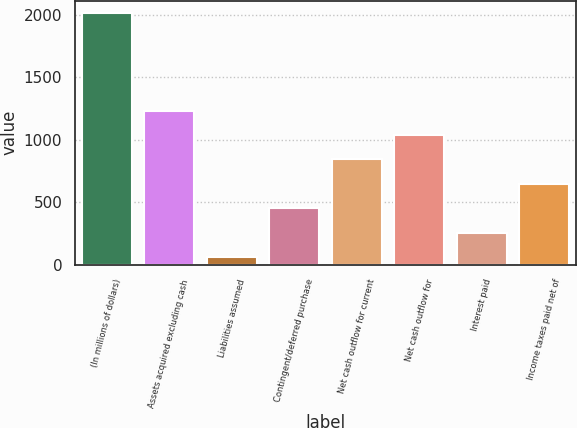Convert chart. <chart><loc_0><loc_0><loc_500><loc_500><bar_chart><fcel>(In millions of dollars)<fcel>Assets acquired excluding cash<fcel>Liabilities assumed<fcel>Contingent/deferred purchase<fcel>Net cash outflow for current<fcel>Net cash outflow for<fcel>Interest paid<fcel>Income taxes paid net of<nl><fcel>2014<fcel>1234<fcel>64<fcel>454<fcel>844<fcel>1039<fcel>259<fcel>649<nl></chart> 